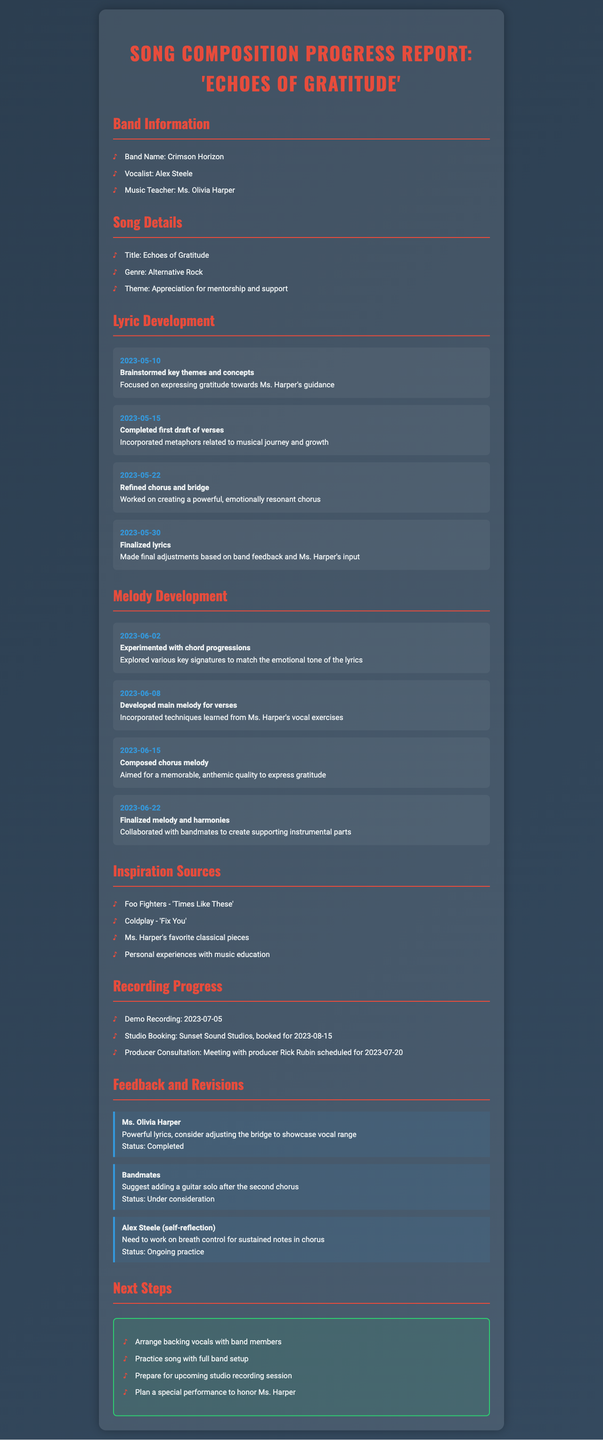what is the title of the song? The title of the song is presented in the song details section of the document.
Answer: Echoes of Gratitude who is the vocalist of the band? The vocalist's name is listed under the band information section of the report.
Answer: Alex Steele when was the demo recording scheduled? The demo recording date is found in the recording progress section.
Answer: 2023-07-05 what feedback did Ms. Harper give on the lyrics? Ms. Harper’s comments are detailed in the feedback and revisions section concerning the lyrics.
Answer: Powerful lyrics, consider adjusting the bridge to showcase vocal range what is the theme of the song? The theme is specified in the song details section.
Answer: Appreciation for mentorship and support how many lyric development entries are there? The number of lyric development entries can be counted in the lyric development section.
Answer: Four what is the next step planned after preparing for the studio recording session? The next steps are outlined at the end of the report.
Answer: Plan a special performance to honor Ms. Harper who is the producer for the consultation meeting? The producer's name is mentioned in the recording progress section.
Answer: Rick Rubin what metaphorical focus was addressed in the first draft of the verses? The metaphorical focus is noted in the lyric development section concerning the first draft.
Answer: Musical journey and growth 